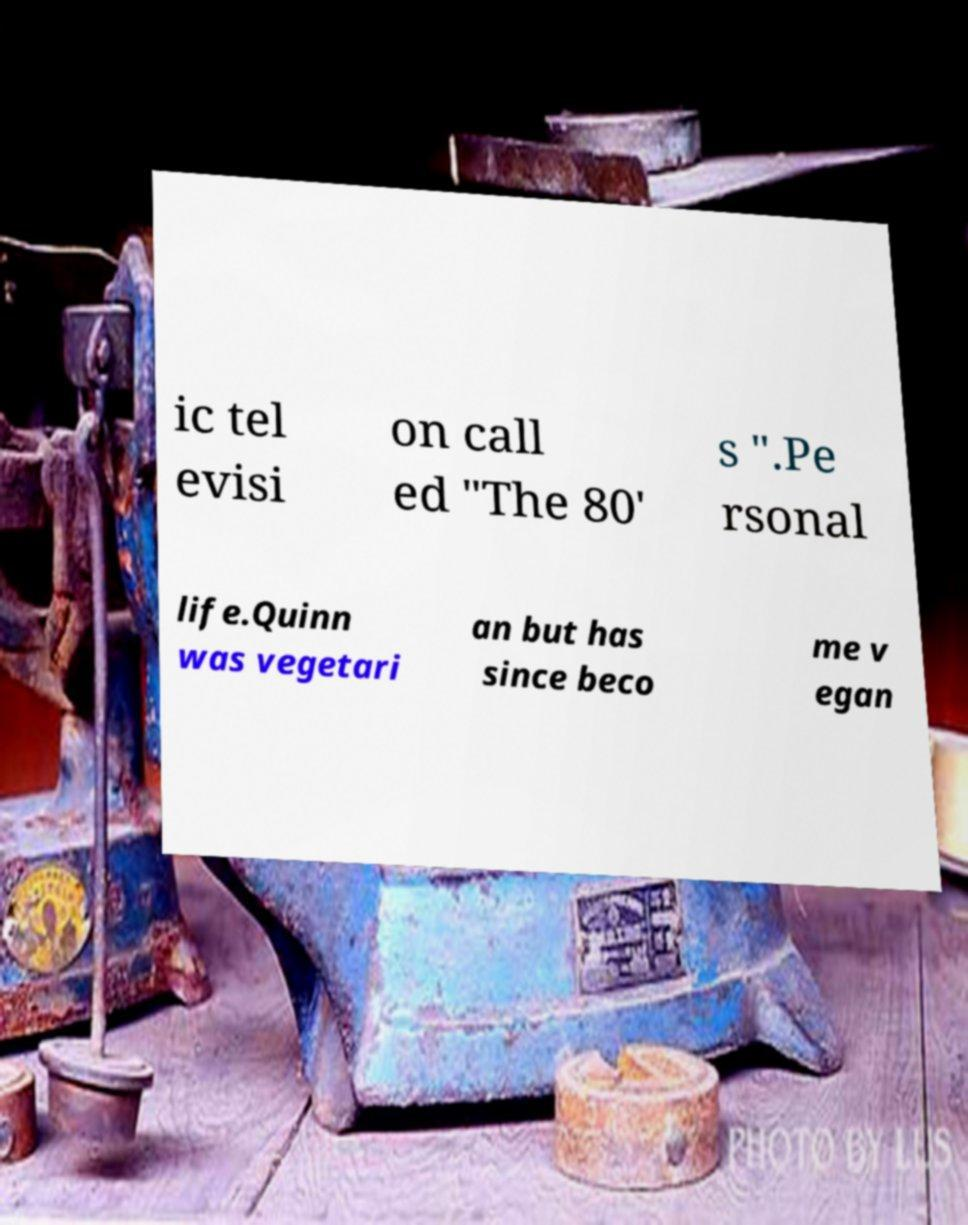Could you extract and type out the text from this image? ic tel evisi on call ed "The 80' s ".Pe rsonal life.Quinn was vegetari an but has since beco me v egan 